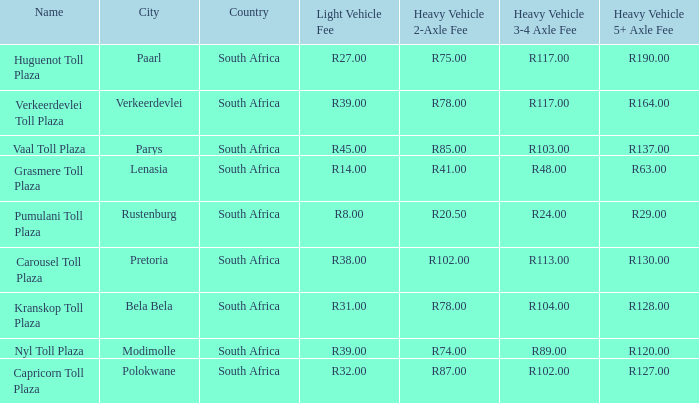What is the location of the Carousel toll plaza? Between pretoria and bela bela. 